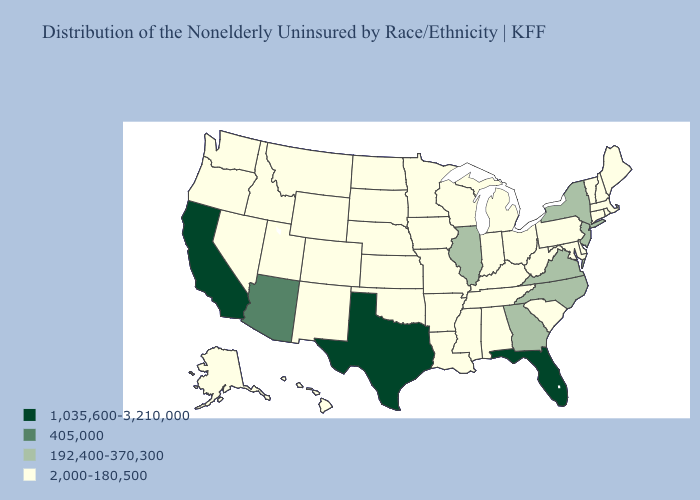Name the states that have a value in the range 1,035,600-3,210,000?
Write a very short answer. California, Florida, Texas. What is the highest value in states that border North Dakota?
Answer briefly. 2,000-180,500. Does Maryland have the highest value in the USA?
Short answer required. No. What is the value of Rhode Island?
Keep it brief. 2,000-180,500. What is the value of Nebraska?
Give a very brief answer. 2,000-180,500. Does the map have missing data?
Quick response, please. No. Among the states that border New Mexico , which have the highest value?
Concise answer only. Texas. What is the lowest value in the West?
Give a very brief answer. 2,000-180,500. Among the states that border North Carolina , does Tennessee have the lowest value?
Short answer required. Yes. Does Florida have the highest value in the South?
Give a very brief answer. Yes. What is the value of Pennsylvania?
Write a very short answer. 2,000-180,500. What is the value of Mississippi?
Short answer required. 2,000-180,500. Among the states that border Nebraska , which have the lowest value?
Quick response, please. Colorado, Iowa, Kansas, Missouri, South Dakota, Wyoming. What is the highest value in states that border Wisconsin?
Be succinct. 192,400-370,300. 